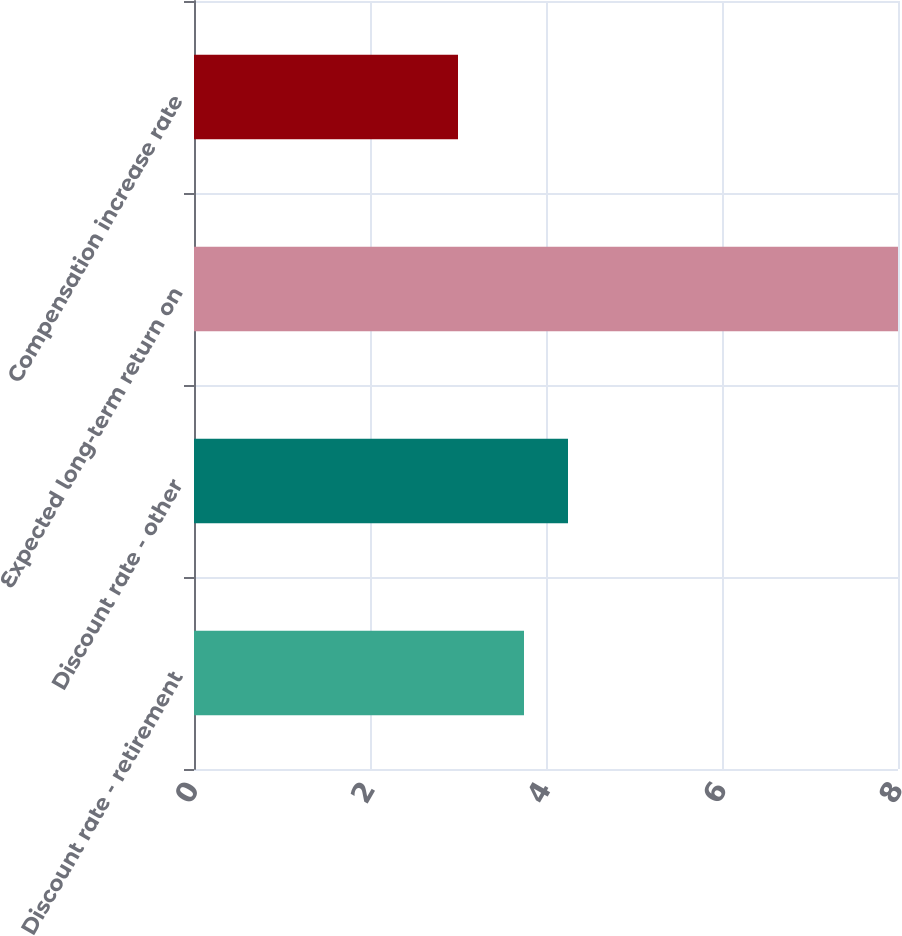Convert chart. <chart><loc_0><loc_0><loc_500><loc_500><bar_chart><fcel>Discount rate - retirement<fcel>Discount rate - other<fcel>Expected long-term return on<fcel>Compensation increase rate<nl><fcel>3.75<fcel>4.25<fcel>8<fcel>3<nl></chart> 